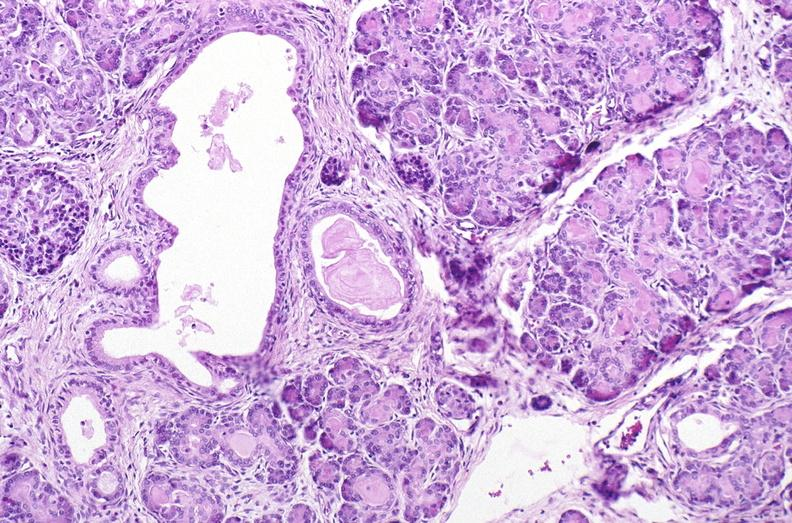does cryptosporidia show cystic fibrosis?
Answer the question using a single word or phrase. No 